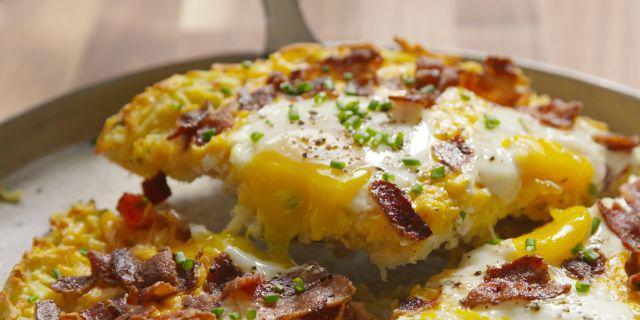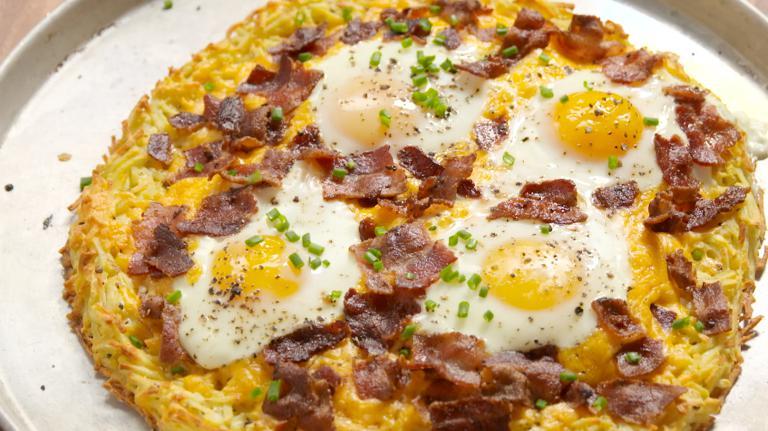The first image is the image on the left, the second image is the image on the right. Considering the images on both sides, is "Both pizzas are cut into slices." valid? Answer yes or no. No. The first image is the image on the left, the second image is the image on the right. Analyze the images presented: Is the assertion "There are two round pizzas and at least one has avocados in the middle of the pizza." valid? Answer yes or no. No. 